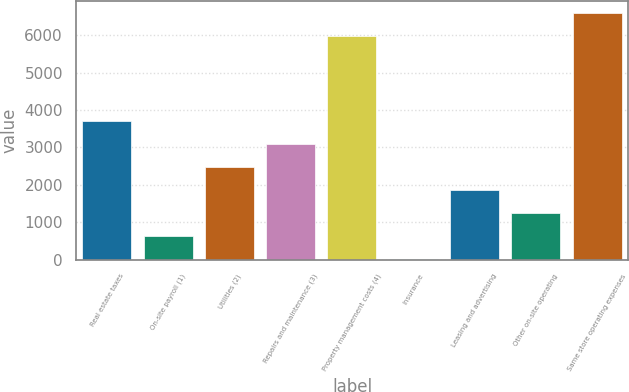<chart> <loc_0><loc_0><loc_500><loc_500><bar_chart><fcel>Real estate taxes<fcel>On-site payroll (1)<fcel>Utilities (2)<fcel>Repairs and maintenance (3)<fcel>Property management costs (4)<fcel>Insurance<fcel>Leasing and advertising<fcel>Other on-site operating<fcel>Same store operating expenses<nl><fcel>3701<fcel>633.5<fcel>2474<fcel>3087.5<fcel>5973<fcel>20<fcel>1860.5<fcel>1247<fcel>6586.5<nl></chart> 